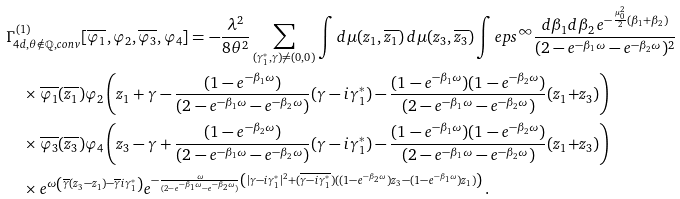Convert formula to latex. <formula><loc_0><loc_0><loc_500><loc_500>& \Gamma ^ { ( 1 ) } _ { 4 d , \theta \notin \mathbb { Q } , c o n v } [ \overline { \varphi _ { 1 } } , \varphi _ { 2 } , \overline { \varphi _ { 3 } } , \varphi _ { 4 } ] = - \frac { \lambda ^ { 2 } } { 8 \theta ^ { 2 } } \sum _ { ( \gamma _ { 1 } ^ { * } , \gamma ) \neq ( 0 , 0 ) } \int d \mu ( z _ { 1 } , \overline { z _ { 1 } } ) \, d \mu ( z _ { 3 } , \overline { z _ { 3 } } ) \int _ { \ } e p s ^ { \infty } \frac { d \beta _ { 1 } d \beta _ { 2 } \, e ^ { - \frac { \mu _ { 0 } ^ { 2 } } { 2 } ( \beta _ { 1 } + \beta _ { 2 } ) } } { ( 2 - e ^ { - \beta _ { 1 } \omega } - e ^ { - \beta _ { 2 } \omega } ) ^ { 2 } } \\ & \quad \times \overline { \varphi _ { 1 } } ( \overline { z _ { 1 } } ) \varphi _ { 2 } \left ( z _ { 1 } + \gamma - \frac { ( 1 - e ^ { - \beta _ { 1 } \omega } ) } { ( 2 - e ^ { - \beta _ { 1 } \omega } - e ^ { - \beta _ { 2 } \omega } ) } ( \gamma - i \gamma _ { 1 } ^ { * } ) - \frac { ( 1 - e ^ { - \beta _ { 1 } \omega } ) ( 1 - e ^ { - \beta _ { 2 } \omega } ) } { ( 2 - e ^ { - \beta _ { 1 } \omega } - e ^ { - \beta _ { 2 } \omega } ) } ( z _ { 1 } { + } z _ { 3 } ) \right ) \\ & \quad \times \overline { \varphi _ { 3 } } ( \overline { z _ { 3 } } ) \varphi _ { 4 } \left ( z _ { 3 } - \gamma + \frac { ( 1 - e ^ { - \beta _ { 2 } \omega } ) } { ( 2 - e ^ { - \beta _ { 1 } \omega } - e ^ { - \beta _ { 2 } \omega } ) } ( \gamma - i \gamma _ { 1 } ^ { * } ) - \frac { ( 1 - e ^ { - \beta _ { 1 } \omega } ) ( 1 - e ^ { - \beta _ { 2 } \omega } ) } { ( 2 - e ^ { - \beta _ { 1 } \omega } - e ^ { - \beta _ { 2 } \omega } ) } ( z _ { 1 } { + } z _ { 3 } ) \right ) \\ & \quad \times e ^ { \omega \left ( \overline { \gamma } ( z _ { 3 } - z _ { 1 } ) - \overline { \gamma } i \gamma _ { 1 } ^ { * } \right ) } e ^ { - \frac { \omega } { ( 2 - e ^ { - \beta _ { 1 } \omega } - e ^ { - \beta _ { 2 } \omega } ) } \left ( | \gamma - i \gamma _ { 1 } ^ { * } | ^ { 2 } + ( \overline { \gamma - i \gamma _ { 1 } ^ { * } } ) ( ( 1 - e ^ { - \beta _ { 2 } \omega } ) z _ { 3 } - ( 1 - e ^ { - \beta _ { 1 } \omega } ) z _ { 1 } ) \right ) } \, .</formula> 